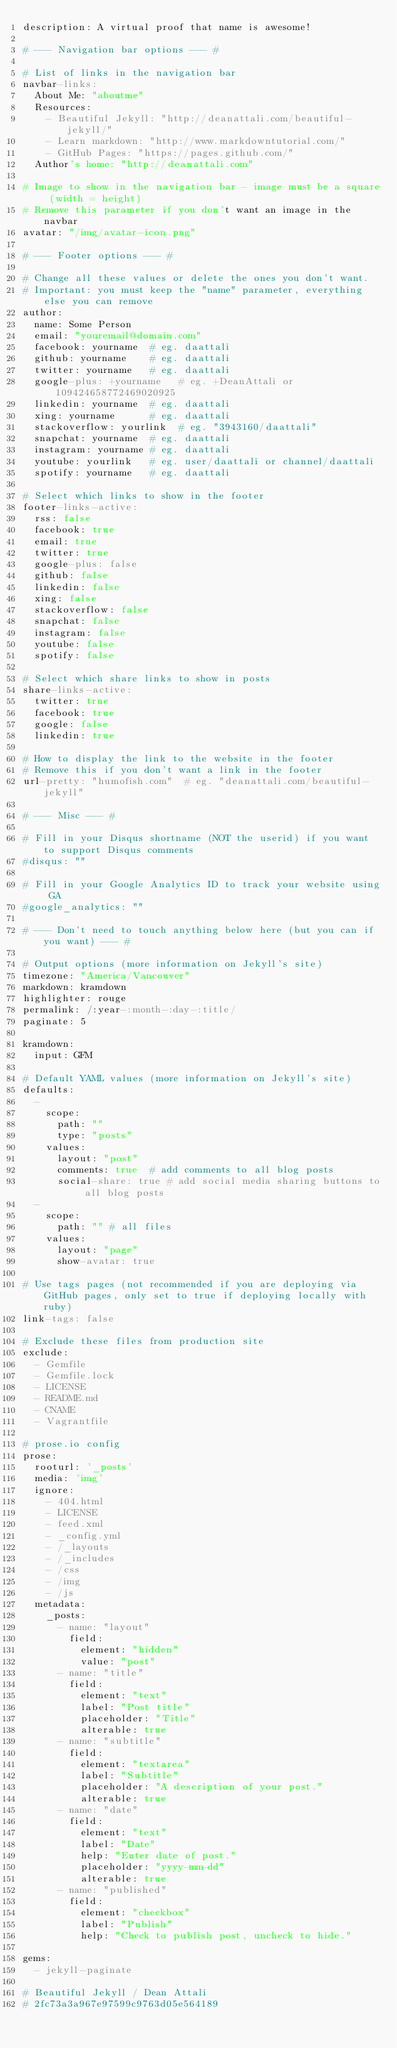Convert code to text. <code><loc_0><loc_0><loc_500><loc_500><_YAML_>description: A virtual proof that name is awesome!

# --- Navigation bar options --- #

# List of links in the navigation bar
navbar-links:
  About Me: "aboutme"
  Resources:
    - Beautiful Jekyll: "http://deanattali.com/beautiful-jekyll/"
    - Learn markdown: "http://www.markdowntutorial.com/"
    - GitHub Pages: "https://pages.github.com/"
  Author's home: "http://deanattali.com"

# Image to show in the navigation bar - image must be a square (width = height)
# Remove this parameter if you don't want an image in the navbar
avatar: "/img/avatar-icon.png"

# --- Footer options --- #

# Change all these values or delete the ones you don't want.
# Important: you must keep the "name" parameter, everything else you can remove
author:
  name: Some Person
  email: "youremail@domain.com"
  facebook: yourname  # eg. daattali
  github: yourname    # eg. daattali
  twitter: yourname   # eg. daattali
  google-plus: +yourname   # eg. +DeanAttali or 109424658772469020925
  linkedin: yourname  # eg. daattali
  xing: yourname      # eg. daattali
  stackoverflow: yourlink  # eg. "3943160/daattali"
  snapchat: yourname  # eg. daattali
  instagram: yourname # eg. daattali
  youtube: yourlink   # eg. user/daattali or channel/daattali
  spotify: yourname   # eg. daattali

# Select which links to show in the footer
footer-links-active:
  rss: false
  facebook: true
  email: true
  twitter: true
  google-plus: false
  github: false
  linkedin: false
  xing: false
  stackoverflow: false
  snapchat: false
  instagram: false
  youtube: false
  spotify: false

# Select which share links to show in posts
share-links-active:
  twitter: true
  facebook: true
  google: false
  linkedin: true

# How to display the link to the website in the footer
# Remove this if you don't want a link in the footer
url-pretty: "humofish.com"  # eg. "deanattali.com/beautiful-jekyll"

# --- Misc --- #

# Fill in your Disqus shortname (NOT the userid) if you want to support Disqus comments
#disqus: ""

# Fill in your Google Analytics ID to track your website using GA
#google_analytics: ""

# --- Don't need to touch anything below here (but you can if you want) --- #

# Output options (more information on Jekyll's site)
timezone: "America/Vancouver"
markdown: kramdown
highlighter: rouge
permalink: /:year-:month-:day-:title/
paginate: 5

kramdown:
  input: GFM

# Default YAML values (more information on Jekyll's site)
defaults:
  -
    scope:
      path: ""
      type: "posts"
    values:
      layout: "post"
      comments: true  # add comments to all blog posts
      social-share: true # add social media sharing buttons to all blog posts
  -
    scope:
      path: "" # all files
    values:
      layout: "page"
      show-avatar: true

# Use tags pages (not recommended if you are deploying via GitHub pages, only set to true if deploying locally with ruby)
link-tags: false

# Exclude these files from production site
exclude:
  - Gemfile
  - Gemfile.lock
  - LICENSE
  - README.md
  - CNAME
  - Vagrantfile

# prose.io config
prose:
  rooturl: '_posts'
  media: 'img'
  ignore:
    - 404.html
    - LICENSE
    - feed.xml
    - _config.yml
    - /_layouts
    - /_includes
    - /css
    - /img
    - /js
  metadata:
    _posts:
      - name: "layout"
        field:
          element: "hidden"
          value: "post"
      - name: "title"
        field:
          element: "text"
          label: "Post title"
          placeholder: "Title"
          alterable: true
      - name: "subtitle"
        field:
          element: "textarea"
          label: "Subtitle"
          placeholder: "A description of your post."
          alterable: true
      - name: "date"
        field:
          element: "text"
          label: "Date"
          help: "Enter date of post."
          placeholder: "yyyy-mm-dd"
          alterable: true
      - name: "published"
        field:
          element: "checkbox"
          label: "Publish"
          help: "Check to publish post, uncheck to hide."

gems:
  - jekyll-paginate

# Beautiful Jekyll / Dean Attali
# 2fc73a3a967e97599c9763d05e564189
</code> 